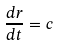Convert formula to latex. <formula><loc_0><loc_0><loc_500><loc_500>\frac { d r } { d t } = c</formula> 